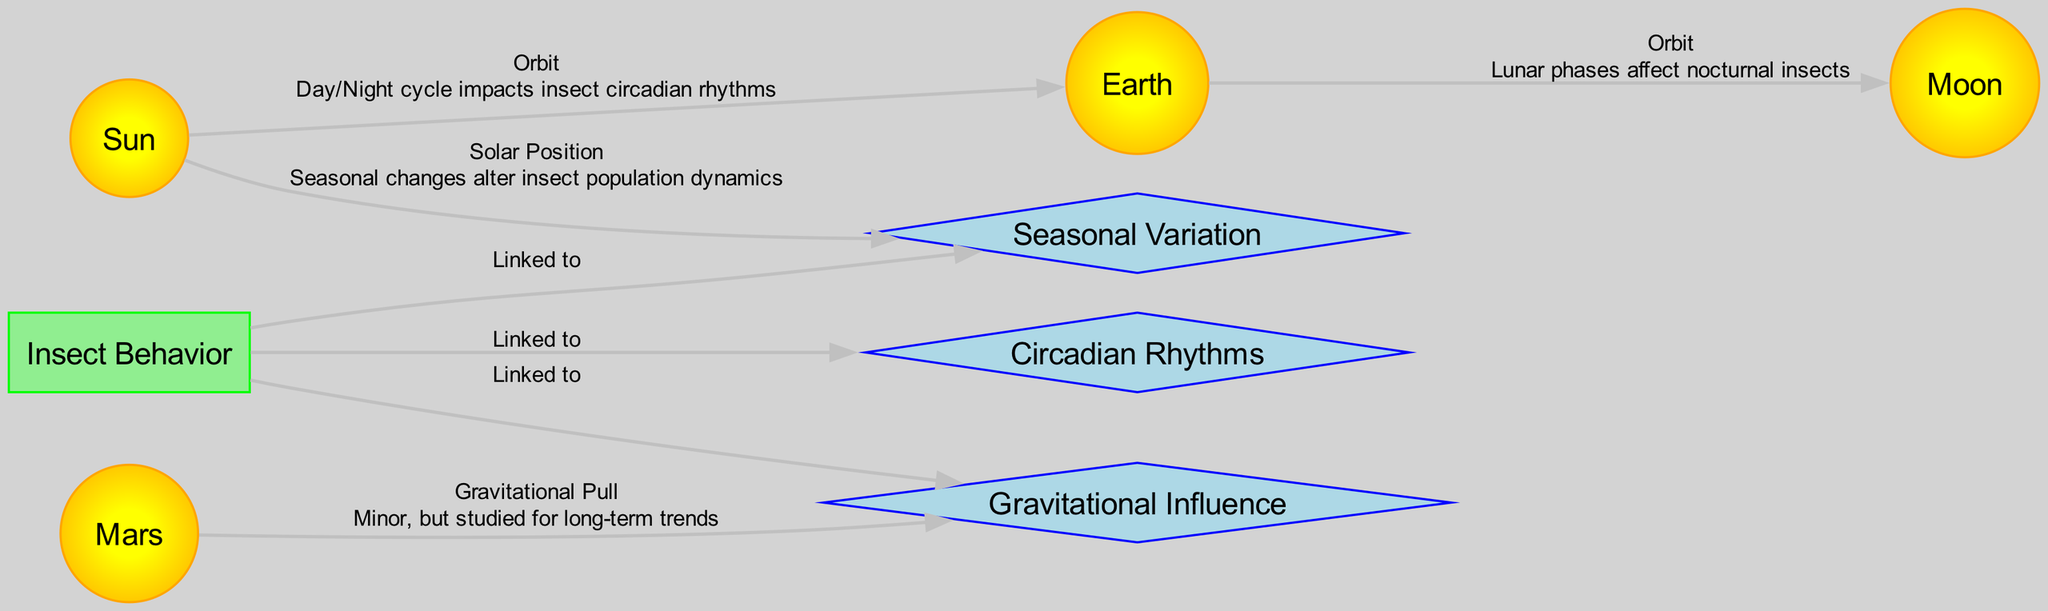What is the central node in the diagram? The central node is 'Sun', which represents the primary celestial body influencing the other nodes through its orbit around the Earth. It is also the starting point for the relationship connections shown.
Answer: Sun How many nodes are present in the diagram? The diagram contains a total of 8 nodes: Sun, Earth, Moon, Mars, Insect Behavior, Circadian Rhythms, Seasonal Variation, and Gravitational Influence.
Answer: 8 What effect does the orbit from Earth to the Moon indicate? The orbit indicates that lunar phases affect nocturnal insects, highlighting a relationship between lunar cycles and insect behavior, particularly for those active at night.
Answer: Lunar phases affect nocturnal insects Which node is linked to seasonal variation? The node 'Insect Behavior' is linked to 'Seasonal Variation' according to the edges representing their relationship in the diagram. This signifies that insect behavior changes with seasons.
Answer: Insect Behavior What type of relationship does 'Mars' have with 'Gravitational Influence'? Mars is depicted to have a relationship of 'Gravitational Pull' towards 'Gravitational Influence', suggesting that while its influence on insects is minor, it is still a point of study for long-term trends.
Answer: Gravitational Pull How many edges lead from the Sun? There are three edges leading from the Sun: one towards Earth, one towards Seasonal Variation, and another towards the gravitational influence on Earth. This shows the Sun's direct relationship with Earth and the broader effects on other factors.
Answer: 3 What is the main effect described for the Sun’s influence on Earth? The main effect is that the day/night cycle impacts insect circadian rhythms, illustrating how light variation from the Sun influences when insects are active.
Answer: Day/Night cycle impacts insect circadian rhythms Which node represents insect behavior directly linked to circadian rhythms? The node 'Insect Behavior' is directly linked to 'Circadian Rhythms', indicating a relationship where insect activity patterns correlate with circadian cycles affected by solar radiation.
Answer: Circadian Rhythms What kind of influence is indicated by the edge from Mars to Gravitational Influence? The edge indicates a 'Gravitational Pull' effect, which is noted to be minor but relevant for examining potential long-term trends in insect behavior related to planetary movements.
Answer: Gravitational Pull 